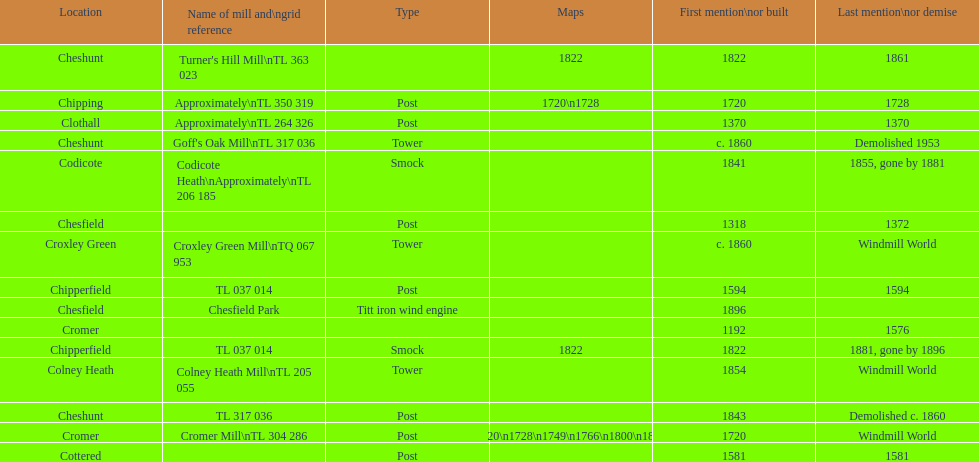How many mills were built or first mentioned after 1800? 8. 